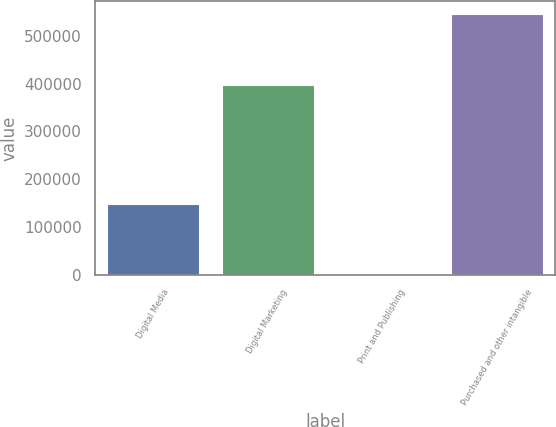Convert chart. <chart><loc_0><loc_0><loc_500><loc_500><bar_chart><fcel>Digital Media<fcel>Digital Marketing<fcel>Print and Publishing<fcel>Purchased and other intangible<nl><fcel>148215<fcel>396786<fcel>35<fcel>545036<nl></chart> 